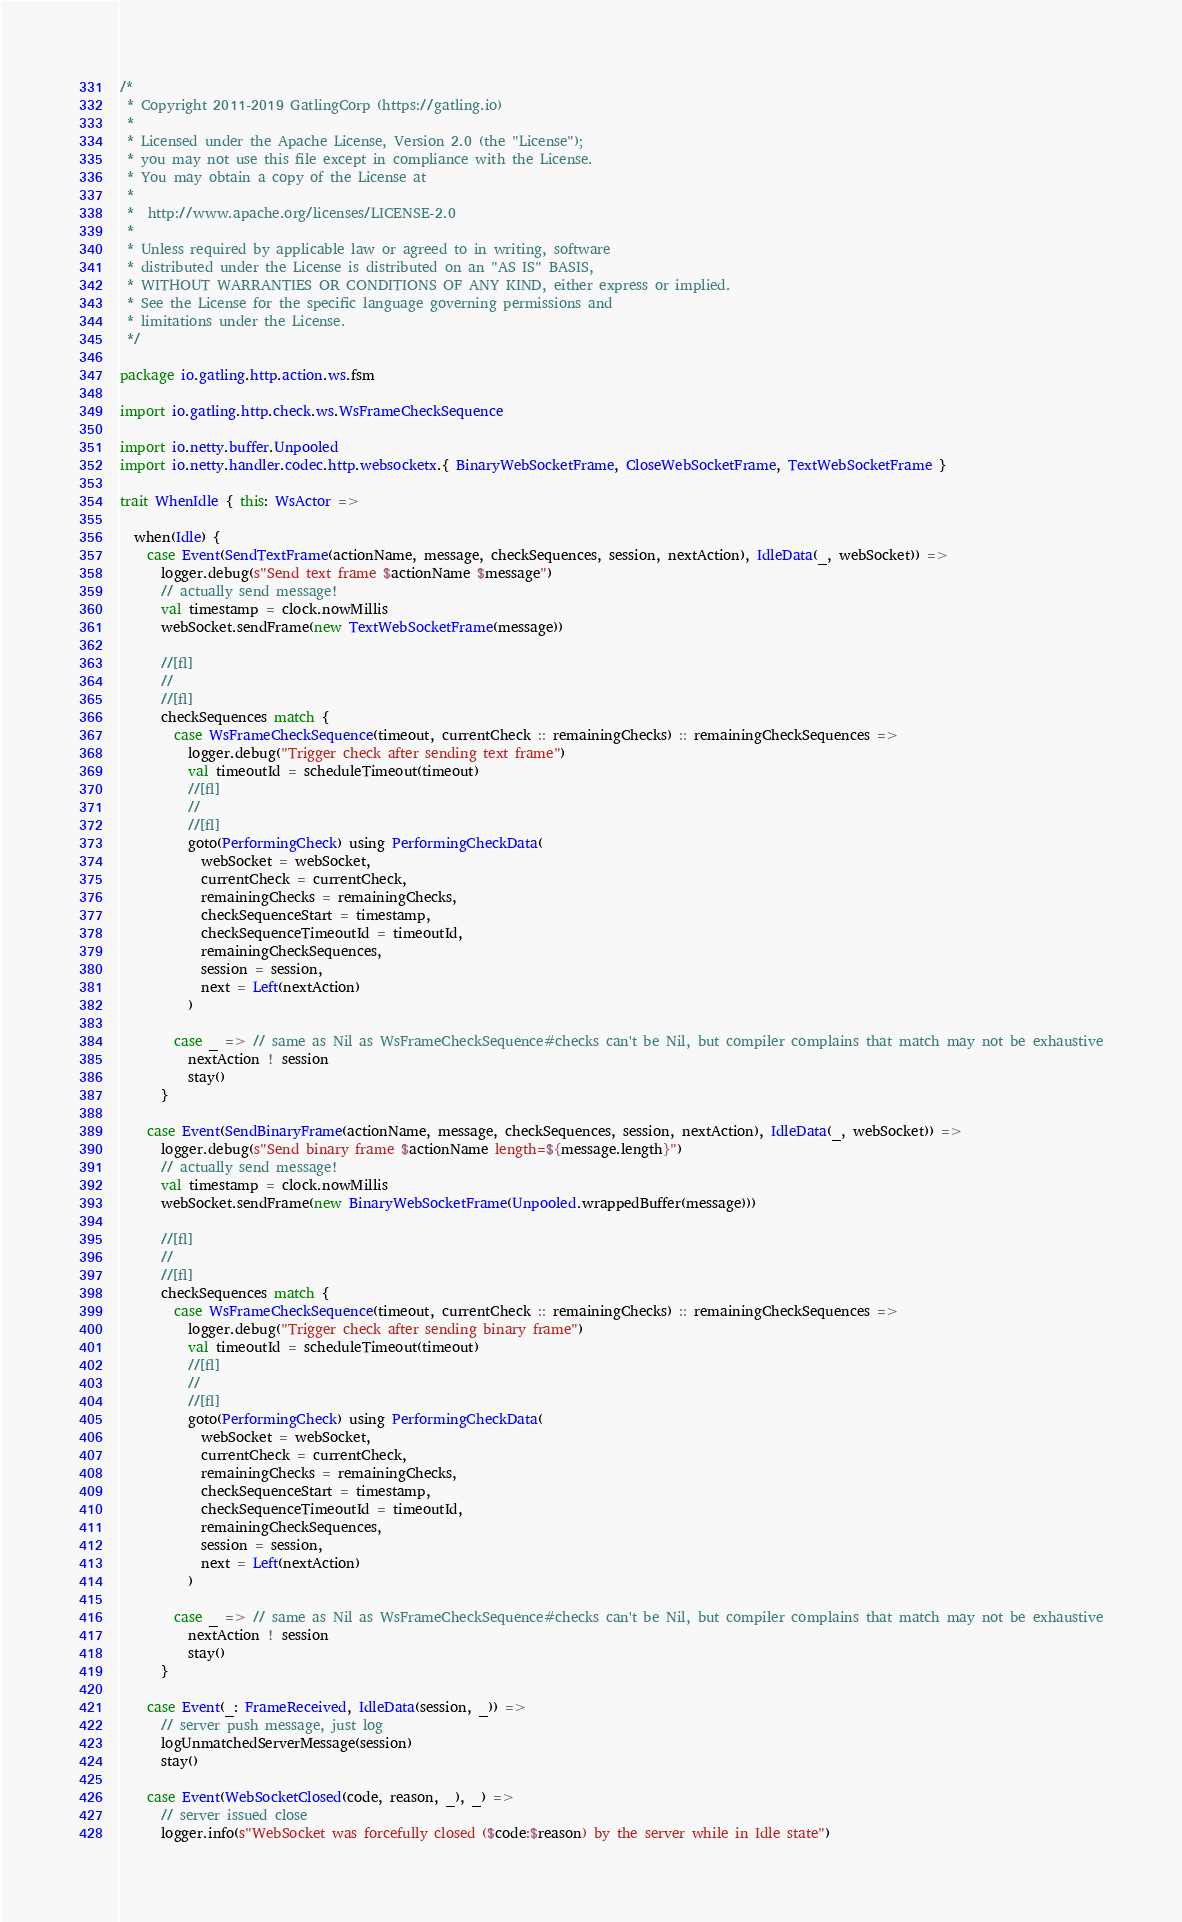<code> <loc_0><loc_0><loc_500><loc_500><_Scala_>/*
 * Copyright 2011-2019 GatlingCorp (https://gatling.io)
 *
 * Licensed under the Apache License, Version 2.0 (the "License");
 * you may not use this file except in compliance with the License.
 * You may obtain a copy of the License at
 *
 *  http://www.apache.org/licenses/LICENSE-2.0
 *
 * Unless required by applicable law or agreed to in writing, software
 * distributed under the License is distributed on an "AS IS" BASIS,
 * WITHOUT WARRANTIES OR CONDITIONS OF ANY KIND, either express or implied.
 * See the License for the specific language governing permissions and
 * limitations under the License.
 */

package io.gatling.http.action.ws.fsm

import io.gatling.http.check.ws.WsFrameCheckSequence

import io.netty.buffer.Unpooled
import io.netty.handler.codec.http.websocketx.{ BinaryWebSocketFrame, CloseWebSocketFrame, TextWebSocketFrame }

trait WhenIdle { this: WsActor =>

  when(Idle) {
    case Event(SendTextFrame(actionName, message, checkSequences, session, nextAction), IdleData(_, webSocket)) =>
      logger.debug(s"Send text frame $actionName $message")
      // actually send message!
      val timestamp = clock.nowMillis
      webSocket.sendFrame(new TextWebSocketFrame(message))

      //[fl]
      //
      //[fl]
      checkSequences match {
        case WsFrameCheckSequence(timeout, currentCheck :: remainingChecks) :: remainingCheckSequences =>
          logger.debug("Trigger check after sending text frame")
          val timeoutId = scheduleTimeout(timeout)
          //[fl]
          //
          //[fl]
          goto(PerformingCheck) using PerformingCheckData(
            webSocket = webSocket,
            currentCheck = currentCheck,
            remainingChecks = remainingChecks,
            checkSequenceStart = timestamp,
            checkSequenceTimeoutId = timeoutId,
            remainingCheckSequences,
            session = session,
            next = Left(nextAction)
          )

        case _ => // same as Nil as WsFrameCheckSequence#checks can't be Nil, but compiler complains that match may not be exhaustive
          nextAction ! session
          stay()
      }

    case Event(SendBinaryFrame(actionName, message, checkSequences, session, nextAction), IdleData(_, webSocket)) =>
      logger.debug(s"Send binary frame $actionName length=${message.length}")
      // actually send message!
      val timestamp = clock.nowMillis
      webSocket.sendFrame(new BinaryWebSocketFrame(Unpooled.wrappedBuffer(message)))

      //[fl]
      //
      //[fl]
      checkSequences match {
        case WsFrameCheckSequence(timeout, currentCheck :: remainingChecks) :: remainingCheckSequences =>
          logger.debug("Trigger check after sending binary frame")
          val timeoutId = scheduleTimeout(timeout)
          //[fl]
          //
          //[fl]
          goto(PerformingCheck) using PerformingCheckData(
            webSocket = webSocket,
            currentCheck = currentCheck,
            remainingChecks = remainingChecks,
            checkSequenceStart = timestamp,
            checkSequenceTimeoutId = timeoutId,
            remainingCheckSequences,
            session = session,
            next = Left(nextAction)
          )

        case _ => // same as Nil as WsFrameCheckSequence#checks can't be Nil, but compiler complains that match may not be exhaustive
          nextAction ! session
          stay()
      }

    case Event(_: FrameReceived, IdleData(session, _)) =>
      // server push message, just log
      logUnmatchedServerMessage(session)
      stay()

    case Event(WebSocketClosed(code, reason, _), _) =>
      // server issued close
      logger.info(s"WebSocket was forcefully closed ($code:$reason) by the server while in Idle state")</code> 